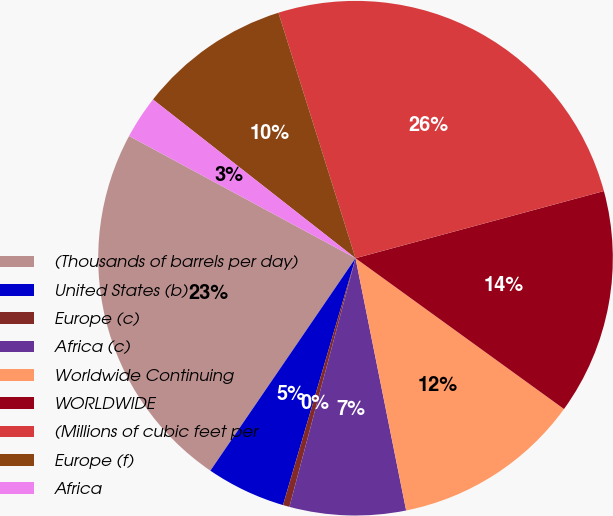Convert chart to OTSL. <chart><loc_0><loc_0><loc_500><loc_500><pie_chart><fcel>(Thousands of barrels per day)<fcel>United States (b)<fcel>Europe (c)<fcel>Africa (c)<fcel>Worldwide Continuing<fcel>WORLDWIDE<fcel>(Millions of cubic feet per<fcel>Europe (f)<fcel>Africa<nl><fcel>23.34%<fcel>4.99%<fcel>0.41%<fcel>7.29%<fcel>11.88%<fcel>14.17%<fcel>25.64%<fcel>9.58%<fcel>2.7%<nl></chart> 